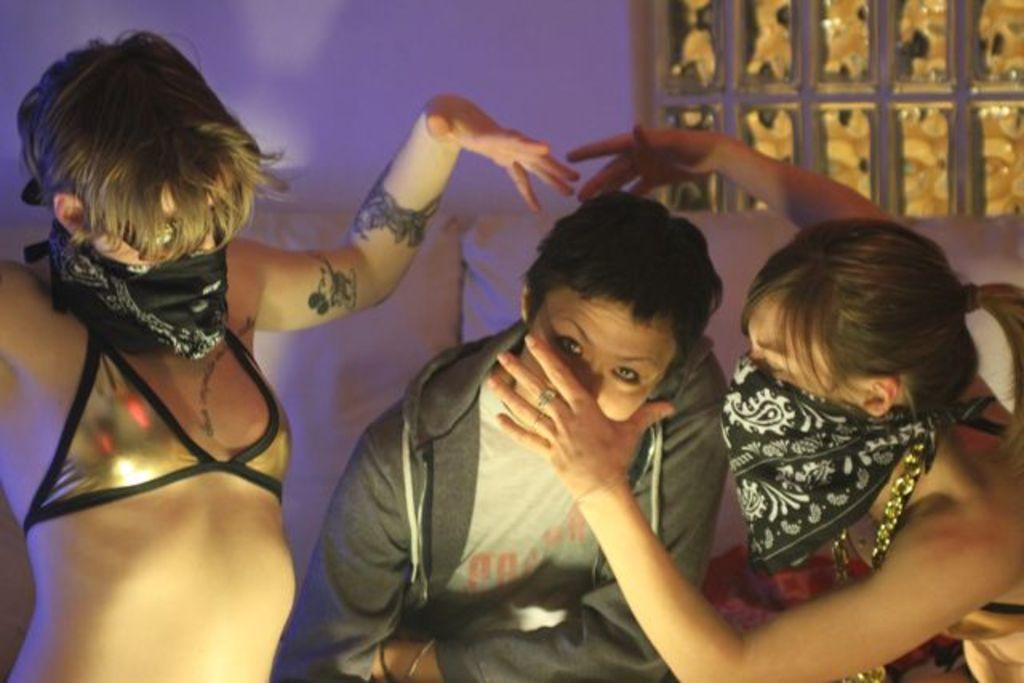How many people are in the image? There are a few people in the image. What can be seen in the background of the image? There is a wall with some objects in the background. What color are the objects in the image? There are white colored objects in the image. What type of bird can be seen flying in the image? There is no bird present in the image. How does the regret affect the people in the image? There is no indication of regret in the image, as it only shows people and a wall with some objects. 